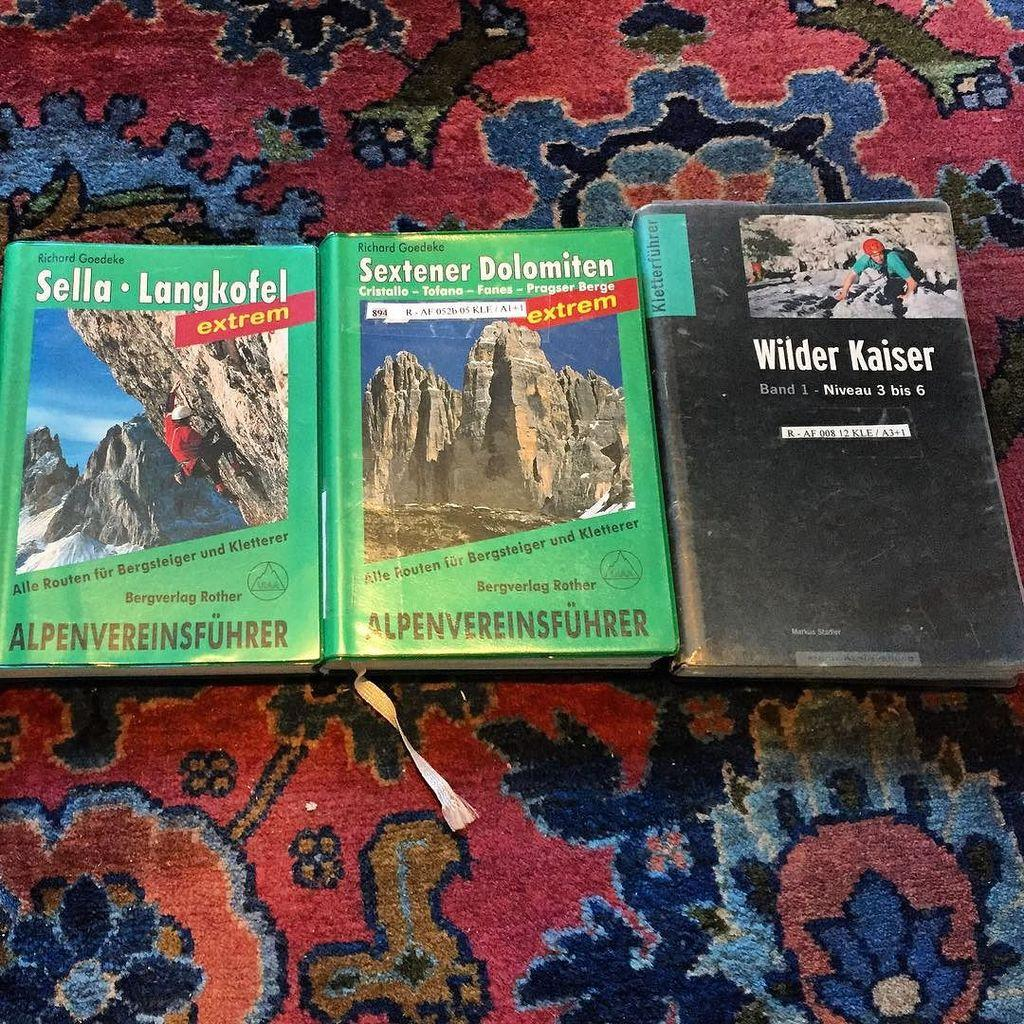<image>
Relay a brief, clear account of the picture shown. Three books on a blanket including Wilder Kaiser. 